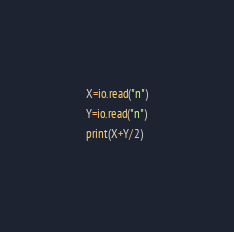Convert code to text. <code><loc_0><loc_0><loc_500><loc_500><_Lua_>X=io.read("n")
Y=io.read("n")
print(X+Y/2)</code> 